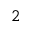Convert formula to latex. <formula><loc_0><loc_0><loc_500><loc_500>^ { 2 }</formula> 